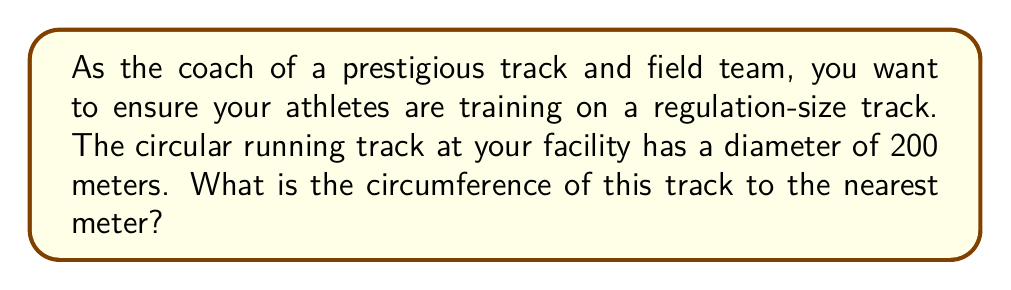Can you answer this question? To solve this problem, we'll follow these steps:

1. Recall the formula for the circumference of a circle:
   $$C = \pi d$$
   where $C$ is the circumference, $\pi$ is pi, and $d$ is the diameter.

2. We're given that the diameter is 200 meters. Let's substitute this into our formula:
   $$C = \pi \cdot 200$$

3. Now, let's use 3.14159 as an approximation for $\pi$:
   $$C = 3.14159 \cdot 200$$

4. Multiply:
   $$C = 628.318$$

5. Round to the nearest meter as requested:
   $$C \approx 628 \text{ meters}$$

Thus, the circumference of the circular running track is approximately 628 meters.
Answer: 628 meters 